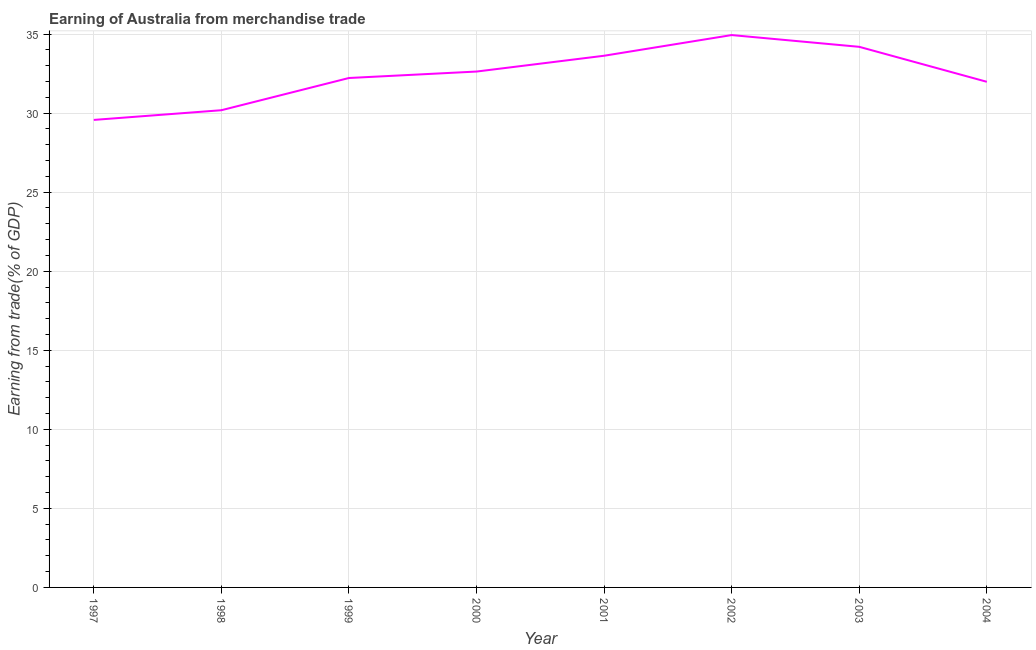What is the earning from merchandise trade in 2001?
Make the answer very short. 33.63. Across all years, what is the maximum earning from merchandise trade?
Provide a short and direct response. 34.94. Across all years, what is the minimum earning from merchandise trade?
Keep it short and to the point. 29.57. What is the sum of the earning from merchandise trade?
Ensure brevity in your answer.  259.35. What is the difference between the earning from merchandise trade in 2001 and 2003?
Your response must be concise. -0.56. What is the average earning from merchandise trade per year?
Provide a succinct answer. 32.42. What is the median earning from merchandise trade?
Give a very brief answer. 32.43. In how many years, is the earning from merchandise trade greater than 14 %?
Your answer should be very brief. 8. Do a majority of the years between 2001 and 2002 (inclusive) have earning from merchandise trade greater than 9 %?
Ensure brevity in your answer.  Yes. What is the ratio of the earning from merchandise trade in 2002 to that in 2004?
Ensure brevity in your answer.  1.09. What is the difference between the highest and the second highest earning from merchandise trade?
Your response must be concise. 0.74. Is the sum of the earning from merchandise trade in 1997 and 2000 greater than the maximum earning from merchandise trade across all years?
Offer a very short reply. Yes. What is the difference between the highest and the lowest earning from merchandise trade?
Provide a succinct answer. 5.37. Does the earning from merchandise trade monotonically increase over the years?
Your response must be concise. No. How many lines are there?
Make the answer very short. 1. How many years are there in the graph?
Offer a terse response. 8. What is the difference between two consecutive major ticks on the Y-axis?
Keep it short and to the point. 5. Does the graph contain any zero values?
Give a very brief answer. No. Does the graph contain grids?
Make the answer very short. Yes. What is the title of the graph?
Provide a succinct answer. Earning of Australia from merchandise trade. What is the label or title of the X-axis?
Ensure brevity in your answer.  Year. What is the label or title of the Y-axis?
Your answer should be very brief. Earning from trade(% of GDP). What is the Earning from trade(% of GDP) in 1997?
Provide a succinct answer. 29.57. What is the Earning from trade(% of GDP) in 1998?
Keep it short and to the point. 30.18. What is the Earning from trade(% of GDP) of 1999?
Your answer should be very brief. 32.22. What is the Earning from trade(% of GDP) of 2000?
Offer a terse response. 32.63. What is the Earning from trade(% of GDP) in 2001?
Your answer should be compact. 33.63. What is the Earning from trade(% of GDP) of 2002?
Provide a short and direct response. 34.94. What is the Earning from trade(% of GDP) of 2003?
Your answer should be compact. 34.19. What is the Earning from trade(% of GDP) of 2004?
Make the answer very short. 31.98. What is the difference between the Earning from trade(% of GDP) in 1997 and 1998?
Your answer should be compact. -0.61. What is the difference between the Earning from trade(% of GDP) in 1997 and 1999?
Keep it short and to the point. -2.65. What is the difference between the Earning from trade(% of GDP) in 1997 and 2000?
Keep it short and to the point. -3.06. What is the difference between the Earning from trade(% of GDP) in 1997 and 2001?
Offer a terse response. -4.06. What is the difference between the Earning from trade(% of GDP) in 1997 and 2002?
Keep it short and to the point. -5.37. What is the difference between the Earning from trade(% of GDP) in 1997 and 2003?
Your answer should be compact. -4.62. What is the difference between the Earning from trade(% of GDP) in 1997 and 2004?
Provide a succinct answer. -2.41. What is the difference between the Earning from trade(% of GDP) in 1998 and 1999?
Your answer should be compact. -2.04. What is the difference between the Earning from trade(% of GDP) in 1998 and 2000?
Provide a short and direct response. -2.45. What is the difference between the Earning from trade(% of GDP) in 1998 and 2001?
Your response must be concise. -3.45. What is the difference between the Earning from trade(% of GDP) in 1998 and 2002?
Provide a succinct answer. -4.75. What is the difference between the Earning from trade(% of GDP) in 1998 and 2003?
Your response must be concise. -4.01. What is the difference between the Earning from trade(% of GDP) in 1998 and 2004?
Make the answer very short. -1.8. What is the difference between the Earning from trade(% of GDP) in 1999 and 2000?
Offer a very short reply. -0.41. What is the difference between the Earning from trade(% of GDP) in 1999 and 2001?
Your response must be concise. -1.41. What is the difference between the Earning from trade(% of GDP) in 1999 and 2002?
Your response must be concise. -2.72. What is the difference between the Earning from trade(% of GDP) in 1999 and 2003?
Ensure brevity in your answer.  -1.97. What is the difference between the Earning from trade(% of GDP) in 1999 and 2004?
Offer a terse response. 0.24. What is the difference between the Earning from trade(% of GDP) in 2000 and 2001?
Your answer should be compact. -1. What is the difference between the Earning from trade(% of GDP) in 2000 and 2002?
Offer a terse response. -2.31. What is the difference between the Earning from trade(% of GDP) in 2000 and 2003?
Provide a succinct answer. -1.56. What is the difference between the Earning from trade(% of GDP) in 2000 and 2004?
Make the answer very short. 0.65. What is the difference between the Earning from trade(% of GDP) in 2001 and 2002?
Offer a terse response. -1.31. What is the difference between the Earning from trade(% of GDP) in 2001 and 2003?
Your response must be concise. -0.56. What is the difference between the Earning from trade(% of GDP) in 2001 and 2004?
Give a very brief answer. 1.65. What is the difference between the Earning from trade(% of GDP) in 2002 and 2003?
Offer a terse response. 0.74. What is the difference between the Earning from trade(% of GDP) in 2002 and 2004?
Provide a succinct answer. 2.96. What is the difference between the Earning from trade(% of GDP) in 2003 and 2004?
Your answer should be very brief. 2.21. What is the ratio of the Earning from trade(% of GDP) in 1997 to that in 1998?
Offer a terse response. 0.98. What is the ratio of the Earning from trade(% of GDP) in 1997 to that in 1999?
Your answer should be very brief. 0.92. What is the ratio of the Earning from trade(% of GDP) in 1997 to that in 2000?
Offer a terse response. 0.91. What is the ratio of the Earning from trade(% of GDP) in 1997 to that in 2001?
Offer a very short reply. 0.88. What is the ratio of the Earning from trade(% of GDP) in 1997 to that in 2002?
Your answer should be compact. 0.85. What is the ratio of the Earning from trade(% of GDP) in 1997 to that in 2003?
Your answer should be very brief. 0.86. What is the ratio of the Earning from trade(% of GDP) in 1997 to that in 2004?
Ensure brevity in your answer.  0.93. What is the ratio of the Earning from trade(% of GDP) in 1998 to that in 1999?
Ensure brevity in your answer.  0.94. What is the ratio of the Earning from trade(% of GDP) in 1998 to that in 2000?
Your answer should be very brief. 0.93. What is the ratio of the Earning from trade(% of GDP) in 1998 to that in 2001?
Provide a succinct answer. 0.9. What is the ratio of the Earning from trade(% of GDP) in 1998 to that in 2002?
Make the answer very short. 0.86. What is the ratio of the Earning from trade(% of GDP) in 1998 to that in 2003?
Provide a succinct answer. 0.88. What is the ratio of the Earning from trade(% of GDP) in 1998 to that in 2004?
Your answer should be very brief. 0.94. What is the ratio of the Earning from trade(% of GDP) in 1999 to that in 2000?
Your response must be concise. 0.99. What is the ratio of the Earning from trade(% of GDP) in 1999 to that in 2001?
Provide a short and direct response. 0.96. What is the ratio of the Earning from trade(% of GDP) in 1999 to that in 2002?
Give a very brief answer. 0.92. What is the ratio of the Earning from trade(% of GDP) in 1999 to that in 2003?
Your answer should be compact. 0.94. What is the ratio of the Earning from trade(% of GDP) in 1999 to that in 2004?
Give a very brief answer. 1.01. What is the ratio of the Earning from trade(% of GDP) in 2000 to that in 2001?
Provide a succinct answer. 0.97. What is the ratio of the Earning from trade(% of GDP) in 2000 to that in 2002?
Provide a short and direct response. 0.93. What is the ratio of the Earning from trade(% of GDP) in 2000 to that in 2003?
Your response must be concise. 0.95. What is the ratio of the Earning from trade(% of GDP) in 2001 to that in 2002?
Your answer should be very brief. 0.96. What is the ratio of the Earning from trade(% of GDP) in 2001 to that in 2003?
Give a very brief answer. 0.98. What is the ratio of the Earning from trade(% of GDP) in 2001 to that in 2004?
Give a very brief answer. 1.05. What is the ratio of the Earning from trade(% of GDP) in 2002 to that in 2004?
Your answer should be compact. 1.09. What is the ratio of the Earning from trade(% of GDP) in 2003 to that in 2004?
Offer a very short reply. 1.07. 